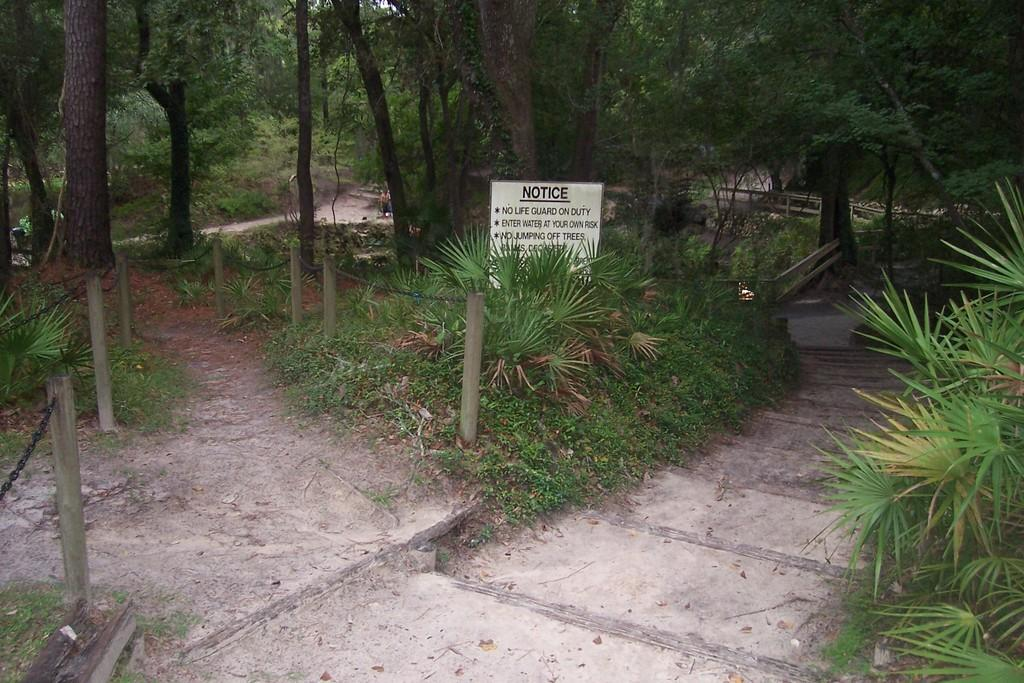What type of location is depicted in the image? The image appears to depict a park. What natural elements can be seen in the image? There are many trees and grass in the image. Is there a designated area for walking in the park? Yes, there is a path for walking in between the grass. What type of leather cover can be seen on the trees in the image? There is no leather cover present on the trees in the image; they are natural trees with bark. 